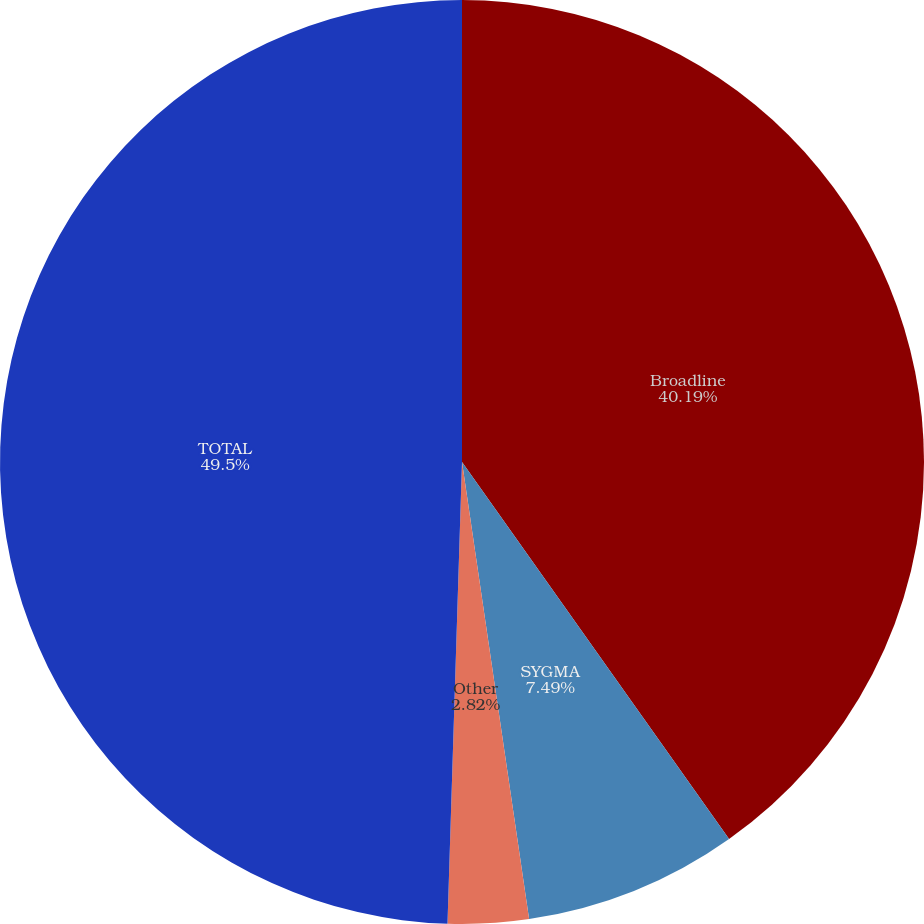<chart> <loc_0><loc_0><loc_500><loc_500><pie_chart><fcel>Broadline<fcel>SYGMA<fcel>Other<fcel>TOTAL<nl><fcel>40.19%<fcel>7.49%<fcel>2.82%<fcel>49.5%<nl></chart> 